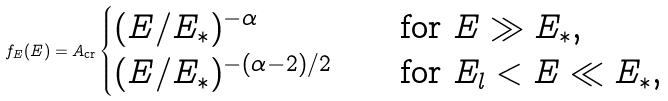<formula> <loc_0><loc_0><loc_500><loc_500>f _ { E } ( E ) = A _ { \text {cr} } \begin{cases} ( E / E _ { \ast } ) ^ { - \alpha } \quad & \text {for } E \gg E _ { \ast } \text {,} \\ ( E / E _ { \ast } ) ^ { - ( \alpha - 2 ) / 2 } \quad & \text {for } E _ { l } < E \ll E _ { \ast } \text {,} \end{cases}</formula> 